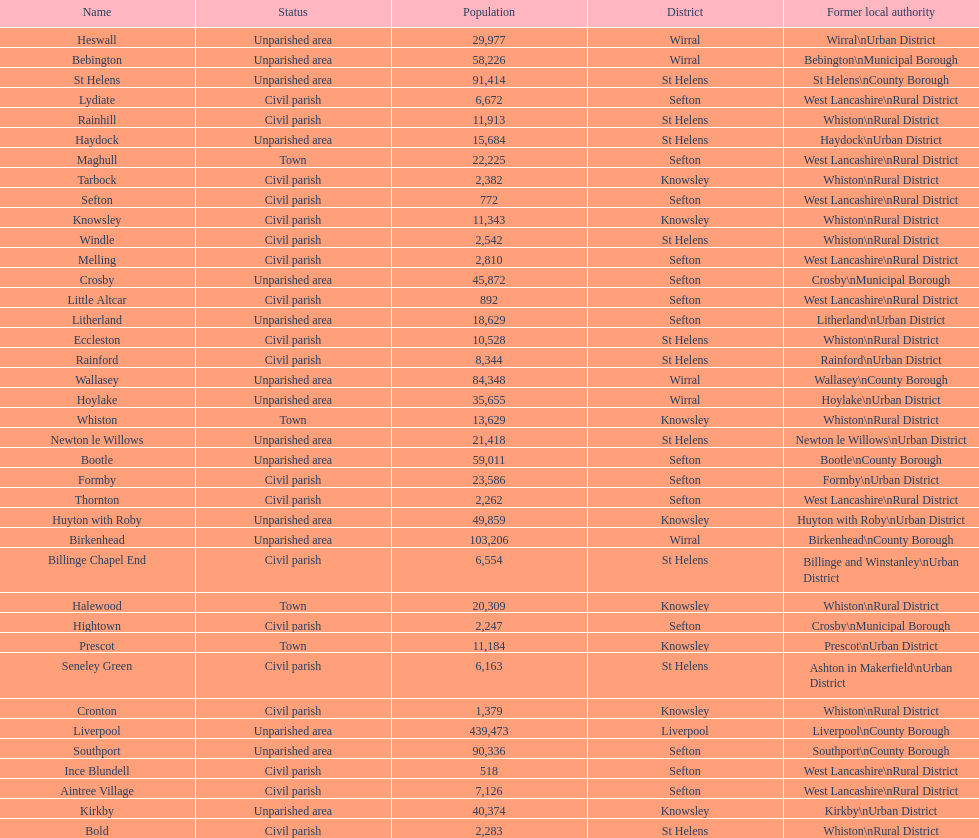Tell me the number of residents in formby. 23,586. 